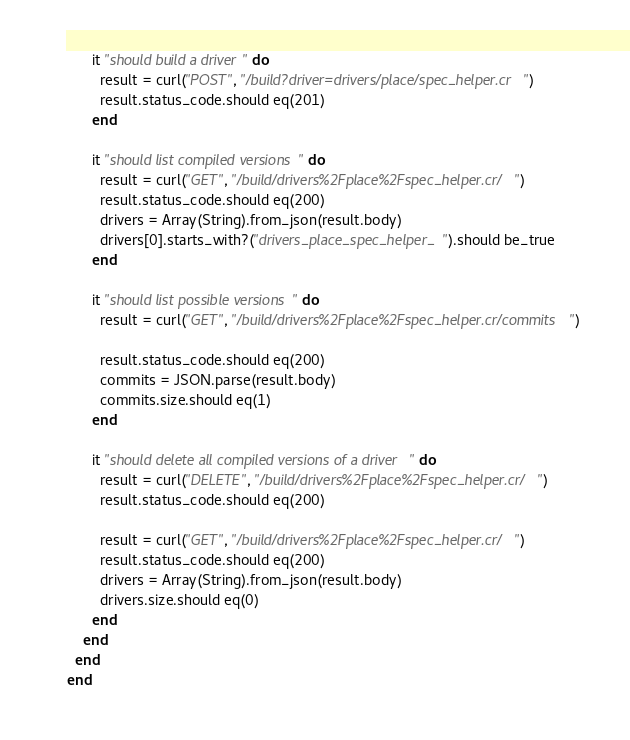Convert code to text. <code><loc_0><loc_0><loc_500><loc_500><_Crystal_>      it "should build a driver" do
        result = curl("POST", "/build?driver=drivers/place/spec_helper.cr")
        result.status_code.should eq(201)
      end

      it "should list compiled versions" do
        result = curl("GET", "/build/drivers%2Fplace%2Fspec_helper.cr/")
        result.status_code.should eq(200)
        drivers = Array(String).from_json(result.body)
        drivers[0].starts_with?("drivers_place_spec_helper_").should be_true
      end

      it "should list possible versions" do
        result = curl("GET", "/build/drivers%2Fplace%2Fspec_helper.cr/commits")

        result.status_code.should eq(200)
        commits = JSON.parse(result.body)
        commits.size.should eq(1)
      end

      it "should delete all compiled versions of a driver" do
        result = curl("DELETE", "/build/drivers%2Fplace%2Fspec_helper.cr/")
        result.status_code.should eq(200)

        result = curl("GET", "/build/drivers%2Fplace%2Fspec_helper.cr/")
        result.status_code.should eq(200)
        drivers = Array(String).from_json(result.body)
        drivers.size.should eq(0)
      end
    end
  end
end
</code> 